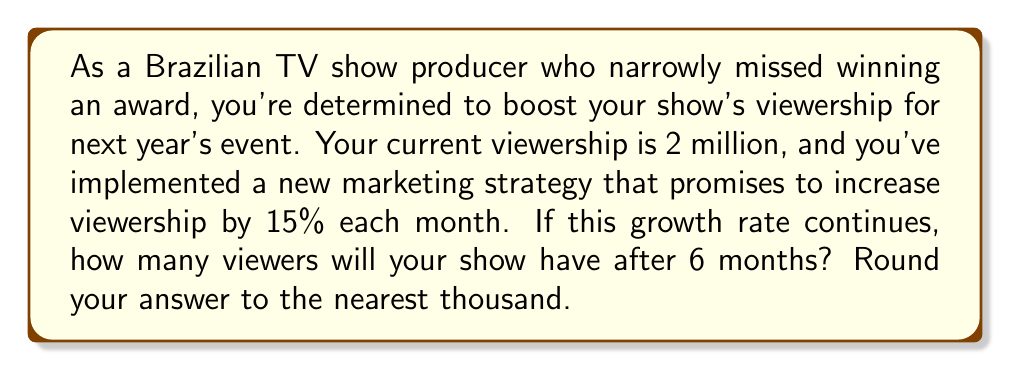Can you solve this math problem? Let's approach this step-by-step:

1) First, we need to identify the key components of exponential growth:
   - Initial value (P): 2 million viewers
   - Growth rate (r): 15% = 0.15
   - Time (t): 6 months

2) The formula for exponential growth is:

   $$ A = P(1 + r)^t $$

   Where A is the final amount, P is the initial amount, r is the growth rate, and t is the time period.

3) Let's plug in our values:

   $$ A = 2,000,000(1 + 0.15)^6 $$

4) Simplify the expression inside the parentheses:

   $$ A = 2,000,000(1.15)^6 $$

5) Now, let's calculate $(1.15)^6$:

   $$ (1.15)^6 \approx 2.3131 $$

6) Multiply this by our initial viewership:

   $$ A = 2,000,000 * 2.3131 = 4,626,200 $$

7) Rounding to the nearest thousand:

   $$ A \approx 4,626,000 $$
Answer: After 6 months, the show will have approximately 4,626,000 viewers. 